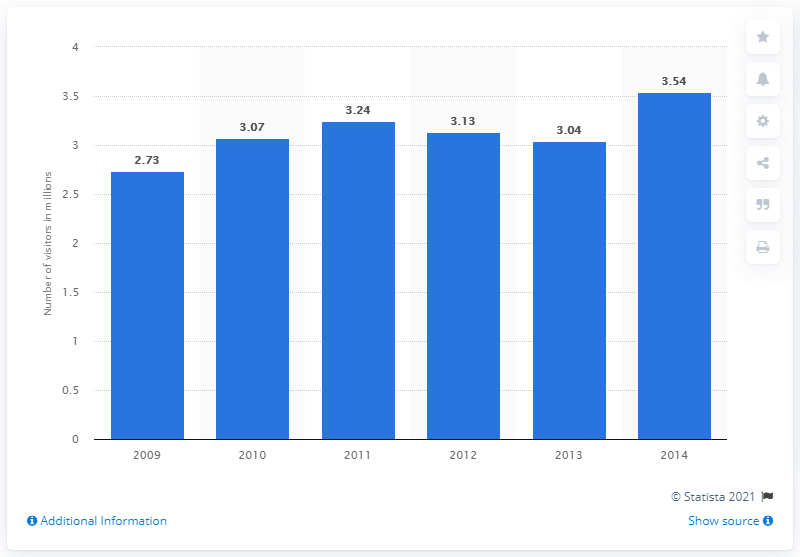Specify some key components in this picture. In 2014, the National Museum of Korea was visited by 3.54 people. 